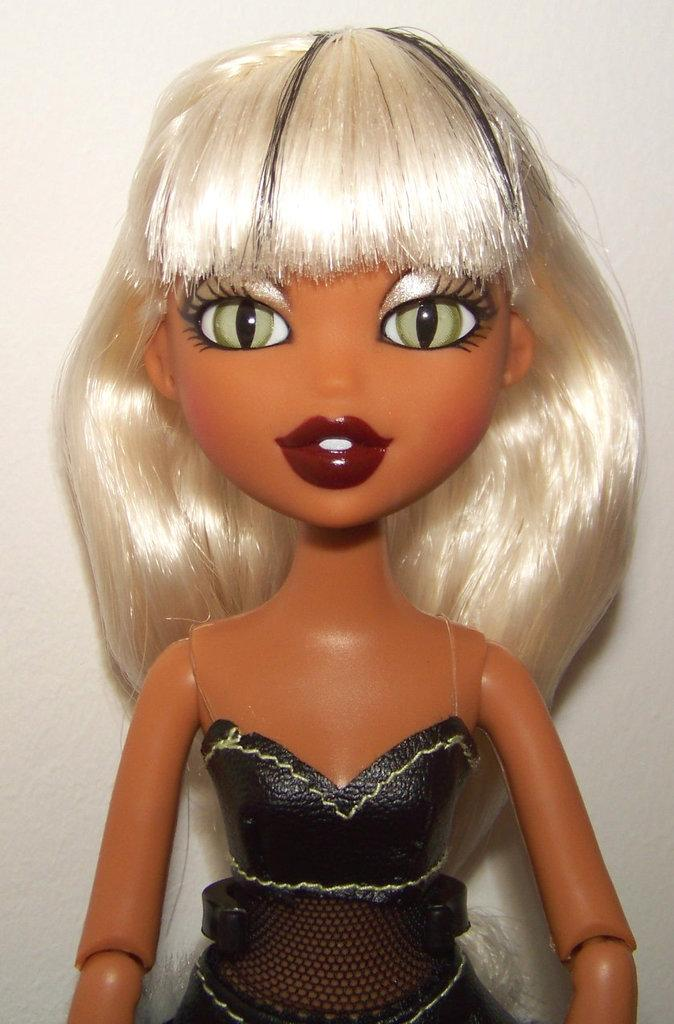What is the main subject in the image? There is a doll in the image. What can be seen behind the doll? There is a wall behind the doll. What type of food is the doll holding in the image? There is no food present in the image; the doll is not holding anything. 